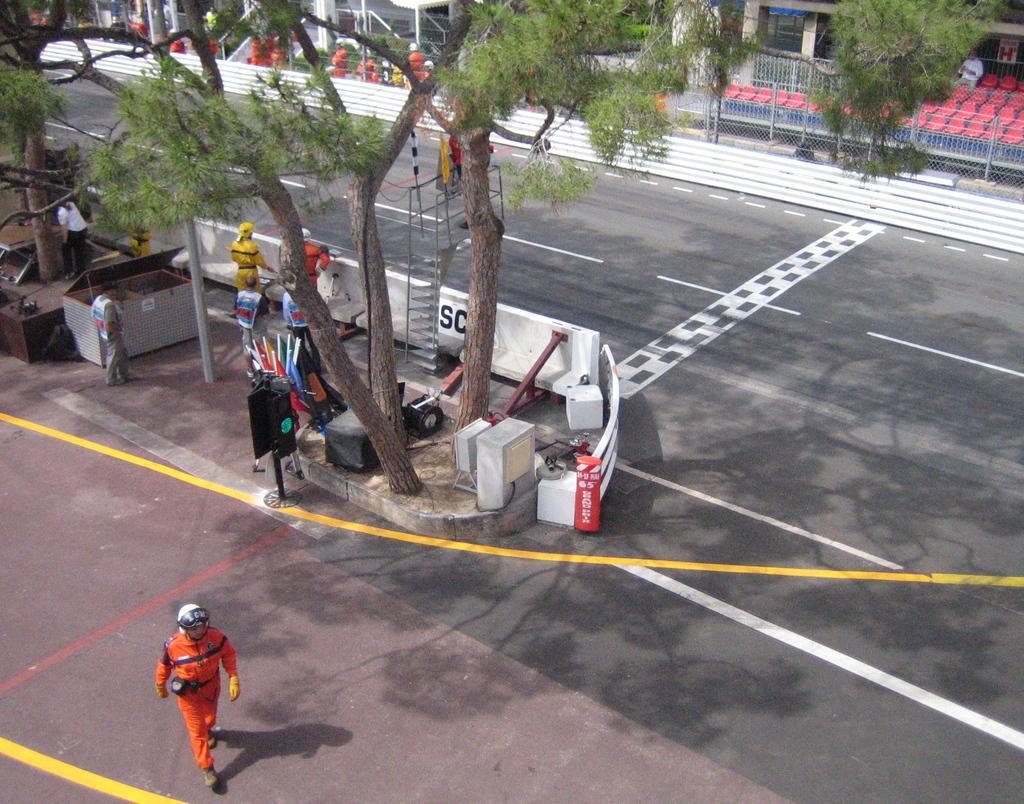Could you give a brief overview of what you see in this image? In the foreground of this image, there is a man walking on the road. In the background, there are persons standing, trees, pole, a ladder, the road, railing, fencing, chairs, buildings and few persons. 